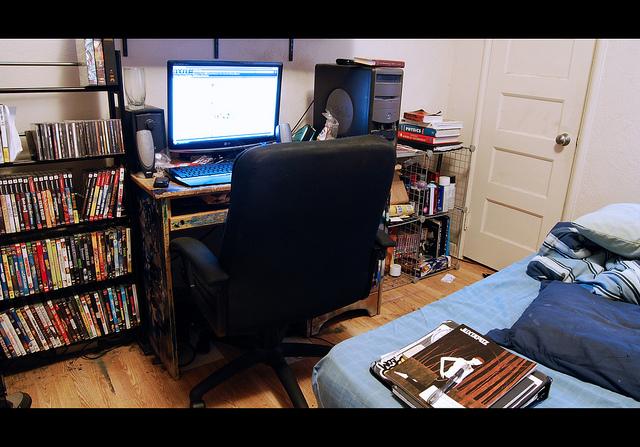What kind of room is this?
Write a very short answer. Bedroom. What is in the cabinet to the left?
Write a very short answer. Movies. Is the monitor on?
Keep it brief. Yes. Are they looking for a movie to watch?
Answer briefly. No. 